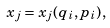Convert formula to latex. <formula><loc_0><loc_0><loc_500><loc_500>x _ { j } = x _ { j } { ( q _ { i } , p _ { i } ) } ,</formula> 